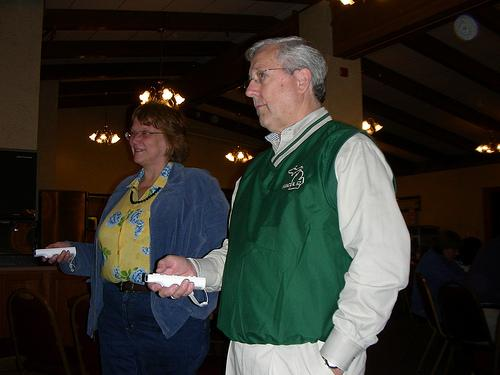Explain the color of the woman's top and its relationship to her overall outfit. The woman is wearing a blue top which complements her short brown hair and black beaded necklace. Describe the type of controller the couple is using and the color of its exterior. The couple is using white game controllers to play the Wii. Comment on the hair color and the type of clothing the man is wearing. The man has short gray hair and is wearing a white dress shirt, a green vest, and white pants. Provide a brief description of the appearance of the man and the woman in the image. The man has short gray hair, glasses, and wears a green vest and white pants, while the woman has short brown hair, glasses, and a blue top. Provide a brief overview of the attire and physical characteristics of both subjects in the image. The man has short gray hair, glasses, a green vest, and white pants, while the woman has short brown hair, glasses, a blue top, and a black necklace. Explain what the man is wearing on his upper body, including the color and style. The man is wearing a white dress shirt and a green vest over it. Mention the primary action taking place in the image and the individuals involved. A woman and a man are playing the Wii, both holding white game controllers. Describe the woman's outfit and hairstyle in the photo. The woman has short brown hair, wearing glasses, a blue top, and a black beaded necklace. List the accessories worn by both the man and the woman in the image. The man is wearing eyeglasses and a wristwatch, while the woman is wearing glasses and a black beaded necklace. Identify the type of electronic device the couple is playing with and the color of the controller. The couple is playing with a Wii console and using white controllers. 